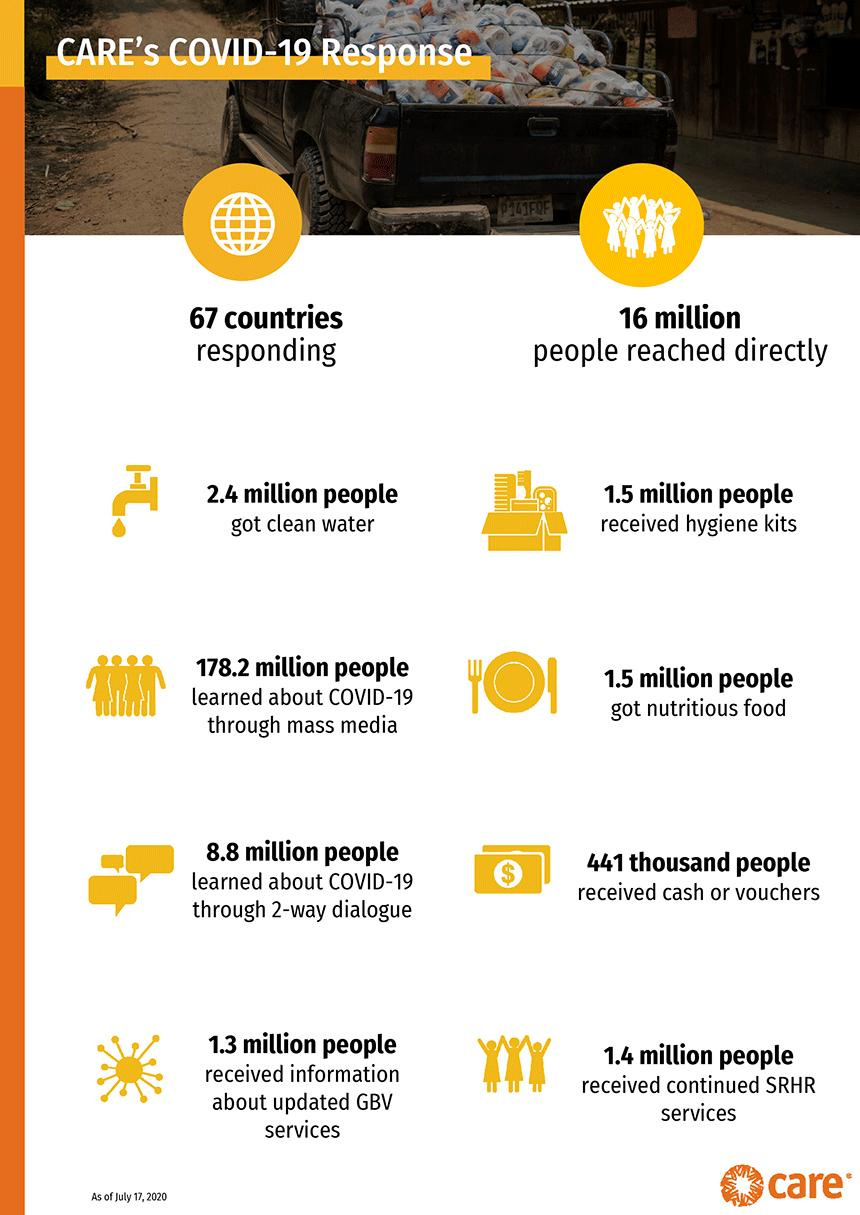Indicate a few pertinent items in this graphic. As of July 17, 2020, approximately 178.2 million people worldwide received information about COVID-19 through mass media with the support of CARE, according to a recent estimate. As of July 17, 2020, Care's Covid-19 mission had distributed hygiene kits to a total of 1.5 million people worldwide. As of July 17, 2020, approximately 441 thousand people around the world received either cash or vouchers as part of Care's Covid-19 mission. As of July 17, 2020, Care's Covid-19 mission had provided continued SRHR services to approximately 1.4 million people worldwide. As of July 17, 2020, 8.8 million people worldwide had learned about COVID-19 through two-way dialogue with the help of CARE, a global humanitarian organization. 